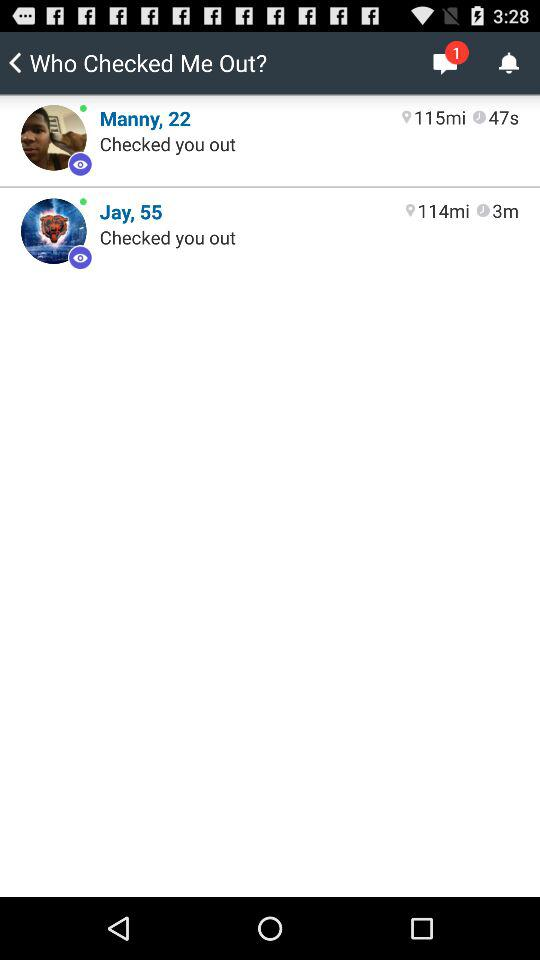How many messages are unread? There is 1 unread message. 